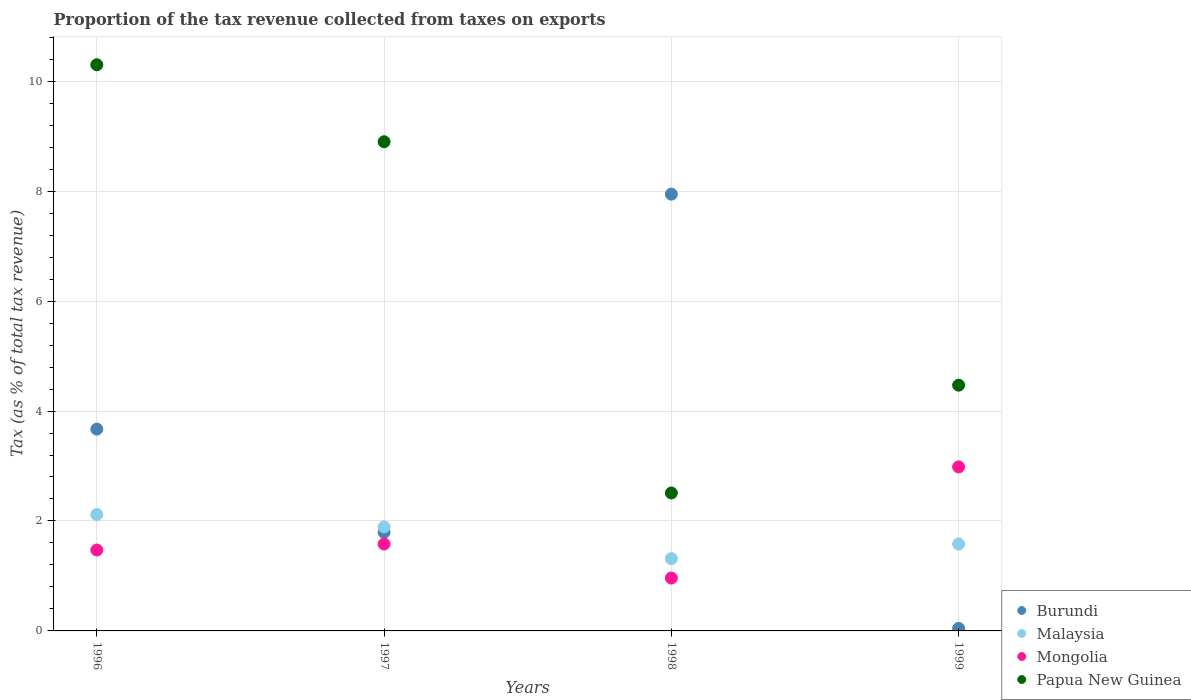How many different coloured dotlines are there?
Provide a short and direct response. 4. What is the proportion of the tax revenue collected in Mongolia in 1997?
Your answer should be very brief. 1.58. Across all years, what is the maximum proportion of the tax revenue collected in Burundi?
Your answer should be very brief. 7.94. Across all years, what is the minimum proportion of the tax revenue collected in Papua New Guinea?
Your response must be concise. 2.51. In which year was the proportion of the tax revenue collected in Mongolia maximum?
Provide a short and direct response. 1999. What is the total proportion of the tax revenue collected in Malaysia in the graph?
Offer a very short reply. 6.9. What is the difference between the proportion of the tax revenue collected in Malaysia in 1997 and that in 1998?
Your answer should be compact. 0.58. What is the difference between the proportion of the tax revenue collected in Burundi in 1997 and the proportion of the tax revenue collected in Malaysia in 1999?
Offer a terse response. 0.21. What is the average proportion of the tax revenue collected in Malaysia per year?
Offer a very short reply. 1.73. In the year 1999, what is the difference between the proportion of the tax revenue collected in Papua New Guinea and proportion of the tax revenue collected in Malaysia?
Your response must be concise. 2.89. What is the ratio of the proportion of the tax revenue collected in Mongolia in 1997 to that in 1998?
Your answer should be compact. 1.64. Is the proportion of the tax revenue collected in Burundi in 1998 less than that in 1999?
Give a very brief answer. No. What is the difference between the highest and the second highest proportion of the tax revenue collected in Burundi?
Make the answer very short. 4.27. What is the difference between the highest and the lowest proportion of the tax revenue collected in Burundi?
Offer a very short reply. 7.9. Is it the case that in every year, the sum of the proportion of the tax revenue collected in Mongolia and proportion of the tax revenue collected in Burundi  is greater than the sum of proportion of the tax revenue collected in Papua New Guinea and proportion of the tax revenue collected in Malaysia?
Your answer should be compact. No. Does the proportion of the tax revenue collected in Papua New Guinea monotonically increase over the years?
Your response must be concise. No. What is the difference between two consecutive major ticks on the Y-axis?
Your response must be concise. 2. Does the graph contain any zero values?
Provide a short and direct response. No. Does the graph contain grids?
Offer a terse response. Yes. How many legend labels are there?
Ensure brevity in your answer.  4. What is the title of the graph?
Your answer should be compact. Proportion of the tax revenue collected from taxes on exports. What is the label or title of the X-axis?
Your answer should be very brief. Years. What is the label or title of the Y-axis?
Your response must be concise. Tax (as % of total tax revenue). What is the Tax (as % of total tax revenue) in Burundi in 1996?
Your response must be concise. 3.67. What is the Tax (as % of total tax revenue) of Malaysia in 1996?
Ensure brevity in your answer.  2.12. What is the Tax (as % of total tax revenue) in Mongolia in 1996?
Keep it short and to the point. 1.47. What is the Tax (as % of total tax revenue) of Papua New Guinea in 1996?
Give a very brief answer. 10.3. What is the Tax (as % of total tax revenue) in Burundi in 1997?
Your answer should be very brief. 1.79. What is the Tax (as % of total tax revenue) in Malaysia in 1997?
Offer a terse response. 1.89. What is the Tax (as % of total tax revenue) in Mongolia in 1997?
Offer a very short reply. 1.58. What is the Tax (as % of total tax revenue) in Papua New Guinea in 1997?
Keep it short and to the point. 8.9. What is the Tax (as % of total tax revenue) in Burundi in 1998?
Your answer should be very brief. 7.94. What is the Tax (as % of total tax revenue) in Malaysia in 1998?
Your answer should be very brief. 1.31. What is the Tax (as % of total tax revenue) of Mongolia in 1998?
Make the answer very short. 0.96. What is the Tax (as % of total tax revenue) in Papua New Guinea in 1998?
Your answer should be compact. 2.51. What is the Tax (as % of total tax revenue) of Burundi in 1999?
Your answer should be very brief. 0.05. What is the Tax (as % of total tax revenue) of Malaysia in 1999?
Your answer should be compact. 1.58. What is the Tax (as % of total tax revenue) in Mongolia in 1999?
Make the answer very short. 2.98. What is the Tax (as % of total tax revenue) in Papua New Guinea in 1999?
Your response must be concise. 4.47. Across all years, what is the maximum Tax (as % of total tax revenue) of Burundi?
Provide a succinct answer. 7.94. Across all years, what is the maximum Tax (as % of total tax revenue) in Malaysia?
Make the answer very short. 2.12. Across all years, what is the maximum Tax (as % of total tax revenue) of Mongolia?
Give a very brief answer. 2.98. Across all years, what is the maximum Tax (as % of total tax revenue) in Papua New Guinea?
Offer a terse response. 10.3. Across all years, what is the minimum Tax (as % of total tax revenue) of Burundi?
Provide a short and direct response. 0.05. Across all years, what is the minimum Tax (as % of total tax revenue) of Malaysia?
Offer a terse response. 1.31. Across all years, what is the minimum Tax (as % of total tax revenue) of Mongolia?
Give a very brief answer. 0.96. Across all years, what is the minimum Tax (as % of total tax revenue) of Papua New Guinea?
Give a very brief answer. 2.51. What is the total Tax (as % of total tax revenue) of Burundi in the graph?
Offer a terse response. 13.45. What is the total Tax (as % of total tax revenue) in Malaysia in the graph?
Your answer should be very brief. 6.9. What is the total Tax (as % of total tax revenue) in Mongolia in the graph?
Offer a terse response. 7. What is the total Tax (as % of total tax revenue) in Papua New Guinea in the graph?
Give a very brief answer. 26.18. What is the difference between the Tax (as % of total tax revenue) of Burundi in 1996 and that in 1997?
Keep it short and to the point. 1.88. What is the difference between the Tax (as % of total tax revenue) in Malaysia in 1996 and that in 1997?
Your answer should be compact. 0.23. What is the difference between the Tax (as % of total tax revenue) in Mongolia in 1996 and that in 1997?
Your response must be concise. -0.11. What is the difference between the Tax (as % of total tax revenue) of Papua New Guinea in 1996 and that in 1997?
Ensure brevity in your answer.  1.4. What is the difference between the Tax (as % of total tax revenue) in Burundi in 1996 and that in 1998?
Keep it short and to the point. -4.27. What is the difference between the Tax (as % of total tax revenue) in Malaysia in 1996 and that in 1998?
Offer a terse response. 0.8. What is the difference between the Tax (as % of total tax revenue) in Mongolia in 1996 and that in 1998?
Provide a succinct answer. 0.51. What is the difference between the Tax (as % of total tax revenue) of Papua New Guinea in 1996 and that in 1998?
Make the answer very short. 7.79. What is the difference between the Tax (as % of total tax revenue) of Burundi in 1996 and that in 1999?
Provide a succinct answer. 3.63. What is the difference between the Tax (as % of total tax revenue) of Malaysia in 1996 and that in 1999?
Ensure brevity in your answer.  0.54. What is the difference between the Tax (as % of total tax revenue) of Mongolia in 1996 and that in 1999?
Offer a very short reply. -1.51. What is the difference between the Tax (as % of total tax revenue) in Papua New Guinea in 1996 and that in 1999?
Your response must be concise. 5.83. What is the difference between the Tax (as % of total tax revenue) in Burundi in 1997 and that in 1998?
Give a very brief answer. -6.15. What is the difference between the Tax (as % of total tax revenue) of Malaysia in 1997 and that in 1998?
Your response must be concise. 0.58. What is the difference between the Tax (as % of total tax revenue) of Mongolia in 1997 and that in 1998?
Provide a short and direct response. 0.62. What is the difference between the Tax (as % of total tax revenue) of Papua New Guinea in 1997 and that in 1998?
Offer a very short reply. 6.39. What is the difference between the Tax (as % of total tax revenue) in Burundi in 1997 and that in 1999?
Provide a succinct answer. 1.75. What is the difference between the Tax (as % of total tax revenue) of Malaysia in 1997 and that in 1999?
Make the answer very short. 0.31. What is the difference between the Tax (as % of total tax revenue) of Mongolia in 1997 and that in 1999?
Provide a short and direct response. -1.4. What is the difference between the Tax (as % of total tax revenue) in Papua New Guinea in 1997 and that in 1999?
Ensure brevity in your answer.  4.43. What is the difference between the Tax (as % of total tax revenue) of Burundi in 1998 and that in 1999?
Offer a very short reply. 7.9. What is the difference between the Tax (as % of total tax revenue) in Malaysia in 1998 and that in 1999?
Provide a short and direct response. -0.27. What is the difference between the Tax (as % of total tax revenue) in Mongolia in 1998 and that in 1999?
Provide a succinct answer. -2.02. What is the difference between the Tax (as % of total tax revenue) in Papua New Guinea in 1998 and that in 1999?
Offer a terse response. -1.96. What is the difference between the Tax (as % of total tax revenue) of Burundi in 1996 and the Tax (as % of total tax revenue) of Malaysia in 1997?
Give a very brief answer. 1.78. What is the difference between the Tax (as % of total tax revenue) in Burundi in 1996 and the Tax (as % of total tax revenue) in Mongolia in 1997?
Ensure brevity in your answer.  2.09. What is the difference between the Tax (as % of total tax revenue) in Burundi in 1996 and the Tax (as % of total tax revenue) in Papua New Guinea in 1997?
Give a very brief answer. -5.23. What is the difference between the Tax (as % of total tax revenue) in Malaysia in 1996 and the Tax (as % of total tax revenue) in Mongolia in 1997?
Ensure brevity in your answer.  0.54. What is the difference between the Tax (as % of total tax revenue) in Malaysia in 1996 and the Tax (as % of total tax revenue) in Papua New Guinea in 1997?
Offer a very short reply. -6.78. What is the difference between the Tax (as % of total tax revenue) of Mongolia in 1996 and the Tax (as % of total tax revenue) of Papua New Guinea in 1997?
Provide a succinct answer. -7.43. What is the difference between the Tax (as % of total tax revenue) of Burundi in 1996 and the Tax (as % of total tax revenue) of Malaysia in 1998?
Your answer should be compact. 2.36. What is the difference between the Tax (as % of total tax revenue) of Burundi in 1996 and the Tax (as % of total tax revenue) of Mongolia in 1998?
Your answer should be compact. 2.71. What is the difference between the Tax (as % of total tax revenue) in Burundi in 1996 and the Tax (as % of total tax revenue) in Papua New Guinea in 1998?
Give a very brief answer. 1.16. What is the difference between the Tax (as % of total tax revenue) of Malaysia in 1996 and the Tax (as % of total tax revenue) of Mongolia in 1998?
Provide a succinct answer. 1.16. What is the difference between the Tax (as % of total tax revenue) of Malaysia in 1996 and the Tax (as % of total tax revenue) of Papua New Guinea in 1998?
Offer a terse response. -0.39. What is the difference between the Tax (as % of total tax revenue) in Mongolia in 1996 and the Tax (as % of total tax revenue) in Papua New Guinea in 1998?
Your answer should be very brief. -1.04. What is the difference between the Tax (as % of total tax revenue) of Burundi in 1996 and the Tax (as % of total tax revenue) of Malaysia in 1999?
Make the answer very short. 2.09. What is the difference between the Tax (as % of total tax revenue) of Burundi in 1996 and the Tax (as % of total tax revenue) of Mongolia in 1999?
Give a very brief answer. 0.69. What is the difference between the Tax (as % of total tax revenue) in Burundi in 1996 and the Tax (as % of total tax revenue) in Papua New Guinea in 1999?
Offer a very short reply. -0.8. What is the difference between the Tax (as % of total tax revenue) in Malaysia in 1996 and the Tax (as % of total tax revenue) in Mongolia in 1999?
Make the answer very short. -0.87. What is the difference between the Tax (as % of total tax revenue) in Malaysia in 1996 and the Tax (as % of total tax revenue) in Papua New Guinea in 1999?
Keep it short and to the point. -2.35. What is the difference between the Tax (as % of total tax revenue) of Mongolia in 1996 and the Tax (as % of total tax revenue) of Papua New Guinea in 1999?
Provide a succinct answer. -3. What is the difference between the Tax (as % of total tax revenue) in Burundi in 1997 and the Tax (as % of total tax revenue) in Malaysia in 1998?
Provide a short and direct response. 0.48. What is the difference between the Tax (as % of total tax revenue) of Burundi in 1997 and the Tax (as % of total tax revenue) of Mongolia in 1998?
Your response must be concise. 0.83. What is the difference between the Tax (as % of total tax revenue) of Burundi in 1997 and the Tax (as % of total tax revenue) of Papua New Guinea in 1998?
Ensure brevity in your answer.  -0.72. What is the difference between the Tax (as % of total tax revenue) of Malaysia in 1997 and the Tax (as % of total tax revenue) of Mongolia in 1998?
Give a very brief answer. 0.93. What is the difference between the Tax (as % of total tax revenue) in Malaysia in 1997 and the Tax (as % of total tax revenue) in Papua New Guinea in 1998?
Provide a short and direct response. -0.62. What is the difference between the Tax (as % of total tax revenue) in Mongolia in 1997 and the Tax (as % of total tax revenue) in Papua New Guinea in 1998?
Offer a terse response. -0.93. What is the difference between the Tax (as % of total tax revenue) in Burundi in 1997 and the Tax (as % of total tax revenue) in Malaysia in 1999?
Your response must be concise. 0.21. What is the difference between the Tax (as % of total tax revenue) of Burundi in 1997 and the Tax (as % of total tax revenue) of Mongolia in 1999?
Offer a very short reply. -1.19. What is the difference between the Tax (as % of total tax revenue) of Burundi in 1997 and the Tax (as % of total tax revenue) of Papua New Guinea in 1999?
Ensure brevity in your answer.  -2.68. What is the difference between the Tax (as % of total tax revenue) of Malaysia in 1997 and the Tax (as % of total tax revenue) of Mongolia in 1999?
Offer a very short reply. -1.09. What is the difference between the Tax (as % of total tax revenue) in Malaysia in 1997 and the Tax (as % of total tax revenue) in Papua New Guinea in 1999?
Your response must be concise. -2.58. What is the difference between the Tax (as % of total tax revenue) in Mongolia in 1997 and the Tax (as % of total tax revenue) in Papua New Guinea in 1999?
Provide a succinct answer. -2.89. What is the difference between the Tax (as % of total tax revenue) of Burundi in 1998 and the Tax (as % of total tax revenue) of Malaysia in 1999?
Provide a short and direct response. 6.36. What is the difference between the Tax (as % of total tax revenue) of Burundi in 1998 and the Tax (as % of total tax revenue) of Mongolia in 1999?
Give a very brief answer. 4.96. What is the difference between the Tax (as % of total tax revenue) in Burundi in 1998 and the Tax (as % of total tax revenue) in Papua New Guinea in 1999?
Your answer should be compact. 3.47. What is the difference between the Tax (as % of total tax revenue) of Malaysia in 1998 and the Tax (as % of total tax revenue) of Mongolia in 1999?
Your answer should be compact. -1.67. What is the difference between the Tax (as % of total tax revenue) of Malaysia in 1998 and the Tax (as % of total tax revenue) of Papua New Guinea in 1999?
Offer a terse response. -3.16. What is the difference between the Tax (as % of total tax revenue) in Mongolia in 1998 and the Tax (as % of total tax revenue) in Papua New Guinea in 1999?
Ensure brevity in your answer.  -3.51. What is the average Tax (as % of total tax revenue) in Burundi per year?
Make the answer very short. 3.36. What is the average Tax (as % of total tax revenue) of Malaysia per year?
Give a very brief answer. 1.73. What is the average Tax (as % of total tax revenue) of Mongolia per year?
Your answer should be very brief. 1.75. What is the average Tax (as % of total tax revenue) in Papua New Guinea per year?
Your answer should be very brief. 6.54. In the year 1996, what is the difference between the Tax (as % of total tax revenue) in Burundi and Tax (as % of total tax revenue) in Malaysia?
Offer a terse response. 1.55. In the year 1996, what is the difference between the Tax (as % of total tax revenue) in Burundi and Tax (as % of total tax revenue) in Mongolia?
Keep it short and to the point. 2.2. In the year 1996, what is the difference between the Tax (as % of total tax revenue) in Burundi and Tax (as % of total tax revenue) in Papua New Guinea?
Your answer should be very brief. -6.63. In the year 1996, what is the difference between the Tax (as % of total tax revenue) in Malaysia and Tax (as % of total tax revenue) in Mongolia?
Make the answer very short. 0.65. In the year 1996, what is the difference between the Tax (as % of total tax revenue) in Malaysia and Tax (as % of total tax revenue) in Papua New Guinea?
Provide a succinct answer. -8.18. In the year 1996, what is the difference between the Tax (as % of total tax revenue) in Mongolia and Tax (as % of total tax revenue) in Papua New Guinea?
Keep it short and to the point. -8.83. In the year 1997, what is the difference between the Tax (as % of total tax revenue) of Burundi and Tax (as % of total tax revenue) of Malaysia?
Give a very brief answer. -0.1. In the year 1997, what is the difference between the Tax (as % of total tax revenue) in Burundi and Tax (as % of total tax revenue) in Mongolia?
Provide a succinct answer. 0.21. In the year 1997, what is the difference between the Tax (as % of total tax revenue) of Burundi and Tax (as % of total tax revenue) of Papua New Guinea?
Provide a short and direct response. -7.1. In the year 1997, what is the difference between the Tax (as % of total tax revenue) of Malaysia and Tax (as % of total tax revenue) of Mongolia?
Your answer should be very brief. 0.31. In the year 1997, what is the difference between the Tax (as % of total tax revenue) in Malaysia and Tax (as % of total tax revenue) in Papua New Guinea?
Your answer should be compact. -7.01. In the year 1997, what is the difference between the Tax (as % of total tax revenue) in Mongolia and Tax (as % of total tax revenue) in Papua New Guinea?
Keep it short and to the point. -7.32. In the year 1998, what is the difference between the Tax (as % of total tax revenue) in Burundi and Tax (as % of total tax revenue) in Malaysia?
Provide a succinct answer. 6.63. In the year 1998, what is the difference between the Tax (as % of total tax revenue) of Burundi and Tax (as % of total tax revenue) of Mongolia?
Your answer should be very brief. 6.98. In the year 1998, what is the difference between the Tax (as % of total tax revenue) in Burundi and Tax (as % of total tax revenue) in Papua New Guinea?
Ensure brevity in your answer.  5.44. In the year 1998, what is the difference between the Tax (as % of total tax revenue) in Malaysia and Tax (as % of total tax revenue) in Mongolia?
Give a very brief answer. 0.35. In the year 1998, what is the difference between the Tax (as % of total tax revenue) in Malaysia and Tax (as % of total tax revenue) in Papua New Guinea?
Offer a very short reply. -1.19. In the year 1998, what is the difference between the Tax (as % of total tax revenue) in Mongolia and Tax (as % of total tax revenue) in Papua New Guinea?
Provide a short and direct response. -1.55. In the year 1999, what is the difference between the Tax (as % of total tax revenue) in Burundi and Tax (as % of total tax revenue) in Malaysia?
Keep it short and to the point. -1.53. In the year 1999, what is the difference between the Tax (as % of total tax revenue) in Burundi and Tax (as % of total tax revenue) in Mongolia?
Provide a succinct answer. -2.94. In the year 1999, what is the difference between the Tax (as % of total tax revenue) in Burundi and Tax (as % of total tax revenue) in Papua New Guinea?
Your answer should be compact. -4.42. In the year 1999, what is the difference between the Tax (as % of total tax revenue) of Malaysia and Tax (as % of total tax revenue) of Mongolia?
Offer a terse response. -1.4. In the year 1999, what is the difference between the Tax (as % of total tax revenue) of Malaysia and Tax (as % of total tax revenue) of Papua New Guinea?
Ensure brevity in your answer.  -2.89. In the year 1999, what is the difference between the Tax (as % of total tax revenue) in Mongolia and Tax (as % of total tax revenue) in Papua New Guinea?
Ensure brevity in your answer.  -1.49. What is the ratio of the Tax (as % of total tax revenue) in Burundi in 1996 to that in 1997?
Ensure brevity in your answer.  2.05. What is the ratio of the Tax (as % of total tax revenue) in Malaysia in 1996 to that in 1997?
Give a very brief answer. 1.12. What is the ratio of the Tax (as % of total tax revenue) of Mongolia in 1996 to that in 1997?
Provide a short and direct response. 0.93. What is the ratio of the Tax (as % of total tax revenue) in Papua New Guinea in 1996 to that in 1997?
Provide a succinct answer. 1.16. What is the ratio of the Tax (as % of total tax revenue) in Burundi in 1996 to that in 1998?
Your answer should be compact. 0.46. What is the ratio of the Tax (as % of total tax revenue) of Malaysia in 1996 to that in 1998?
Ensure brevity in your answer.  1.61. What is the ratio of the Tax (as % of total tax revenue) in Mongolia in 1996 to that in 1998?
Make the answer very short. 1.53. What is the ratio of the Tax (as % of total tax revenue) in Papua New Guinea in 1996 to that in 1998?
Your answer should be very brief. 4.1. What is the ratio of the Tax (as % of total tax revenue) in Burundi in 1996 to that in 1999?
Make the answer very short. 80.04. What is the ratio of the Tax (as % of total tax revenue) in Malaysia in 1996 to that in 1999?
Offer a very short reply. 1.34. What is the ratio of the Tax (as % of total tax revenue) in Mongolia in 1996 to that in 1999?
Your response must be concise. 0.49. What is the ratio of the Tax (as % of total tax revenue) of Papua New Guinea in 1996 to that in 1999?
Provide a short and direct response. 2.3. What is the ratio of the Tax (as % of total tax revenue) in Burundi in 1997 to that in 1998?
Offer a very short reply. 0.23. What is the ratio of the Tax (as % of total tax revenue) of Malaysia in 1997 to that in 1998?
Provide a short and direct response. 1.44. What is the ratio of the Tax (as % of total tax revenue) of Mongolia in 1997 to that in 1998?
Your answer should be compact. 1.64. What is the ratio of the Tax (as % of total tax revenue) of Papua New Guinea in 1997 to that in 1998?
Provide a short and direct response. 3.55. What is the ratio of the Tax (as % of total tax revenue) of Burundi in 1997 to that in 1999?
Provide a succinct answer. 39.1. What is the ratio of the Tax (as % of total tax revenue) of Malaysia in 1997 to that in 1999?
Make the answer very short. 1.2. What is the ratio of the Tax (as % of total tax revenue) of Mongolia in 1997 to that in 1999?
Offer a terse response. 0.53. What is the ratio of the Tax (as % of total tax revenue) of Papua New Guinea in 1997 to that in 1999?
Make the answer very short. 1.99. What is the ratio of the Tax (as % of total tax revenue) of Burundi in 1998 to that in 1999?
Keep it short and to the point. 173.23. What is the ratio of the Tax (as % of total tax revenue) of Malaysia in 1998 to that in 1999?
Your answer should be compact. 0.83. What is the ratio of the Tax (as % of total tax revenue) of Mongolia in 1998 to that in 1999?
Your answer should be very brief. 0.32. What is the ratio of the Tax (as % of total tax revenue) of Papua New Guinea in 1998 to that in 1999?
Ensure brevity in your answer.  0.56. What is the difference between the highest and the second highest Tax (as % of total tax revenue) of Burundi?
Offer a terse response. 4.27. What is the difference between the highest and the second highest Tax (as % of total tax revenue) in Malaysia?
Keep it short and to the point. 0.23. What is the difference between the highest and the second highest Tax (as % of total tax revenue) in Mongolia?
Give a very brief answer. 1.4. What is the difference between the highest and the second highest Tax (as % of total tax revenue) in Papua New Guinea?
Offer a terse response. 1.4. What is the difference between the highest and the lowest Tax (as % of total tax revenue) of Burundi?
Give a very brief answer. 7.9. What is the difference between the highest and the lowest Tax (as % of total tax revenue) in Malaysia?
Ensure brevity in your answer.  0.8. What is the difference between the highest and the lowest Tax (as % of total tax revenue) in Mongolia?
Your response must be concise. 2.02. What is the difference between the highest and the lowest Tax (as % of total tax revenue) in Papua New Guinea?
Offer a very short reply. 7.79. 